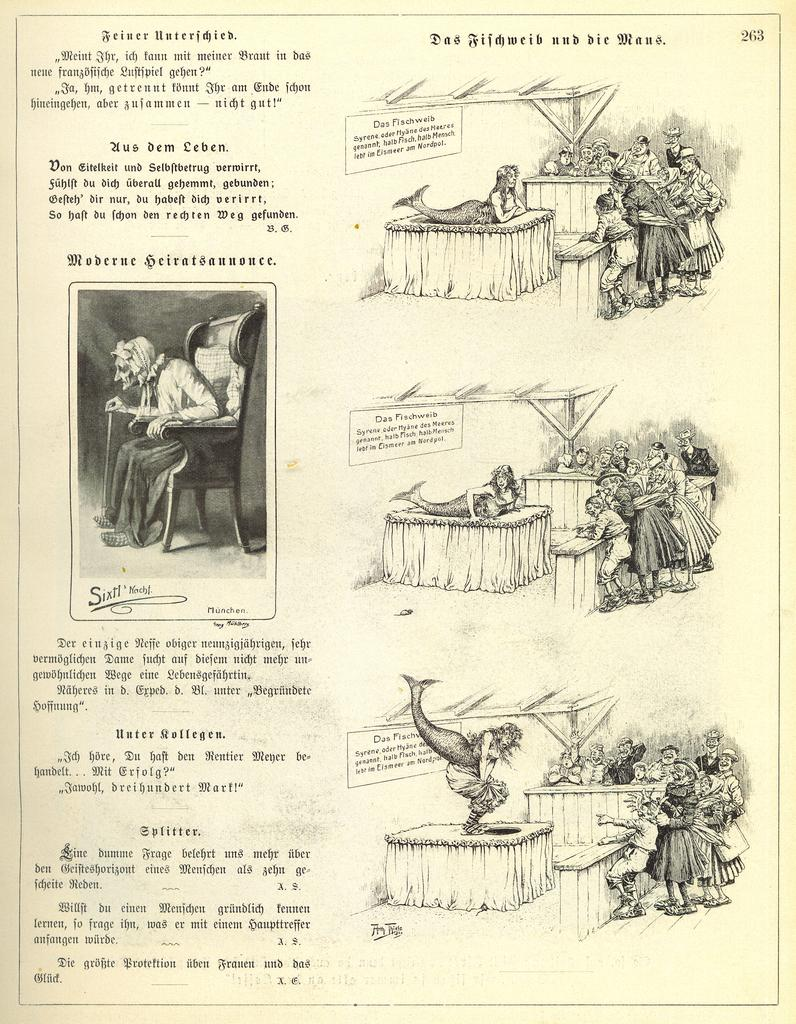What is present on the paper in the image? There is a paper in the image, with text and pictures printed on it. Can you describe the content of the text on the paper? Unfortunately, the specific content of the text cannot be determined from the image alone. What type of pictures are on the paper? The image does not provide enough detail to determine the specific type of pictures on the paper. What type of meal is being served on the paper in the image? There is no meal present on the paper in the image; it only contains text and pictures. Can you describe the weather conditions in the image? The image does not provide any information about the weather conditions, as it only features a paper with text and pictures. 